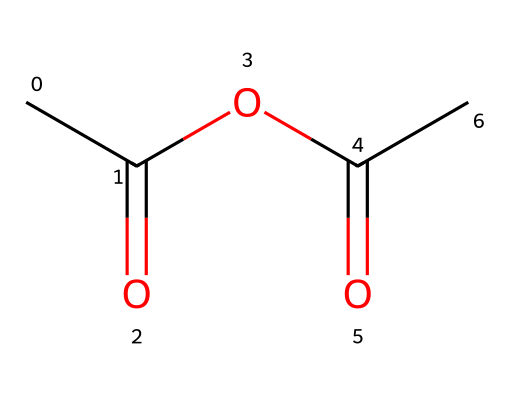What is the molecular formula of acetic anhydride? The molecular formula can be derived from the structure by counting the number of each type of atom. The molecule contains four carbon atoms, six hydrogen atoms, and three oxygen atoms, which adds up to the formula C4H6O3.
Answer: C4H6O3 How many carbon atoms are in the acetic anhydride structure? By examining the provided SMILES, I can see that "CC(=O)" indicates two carbon atoms from the first acetyl group, and there are two additional carbons in the anhydride component, making it four in total.
Answer: 4 What type of functional group is present in acetic anhydride? The structure includes an anhydride functional group, which is characterized by the presence of two carbonyl (C=O) groups bonded through an oxygen atom. Identifying these groups helps recognize it as an anhydride.
Answer: anhydride How many oxygen atoms are connected to carbon atoms in acetic anhydride? Analyzing the structure shows that there are three oxygen atoms, two of which are part of carbonyl groups (C=O) and one is an ether oxygen connecting the two acyl groups.
Answer: 3 What type of bonding is observed between the carbon atoms and oxygen in the carbonyl groups? The bonding in the carbonyl groups consists of double bonds between carbon and oxygen, as indicated by the "=O" notation in the SMILES representation, denoting that there is a strong covalent bond.
Answer: double bond What kind of reaction would acetic anhydride typically participate in? Acetic anhydride is known to participate in acylation reactions, where it can donate acetyl groups to other reactants, indicating that it readily reacts in synthetic organic reactions.
Answer: acylation 